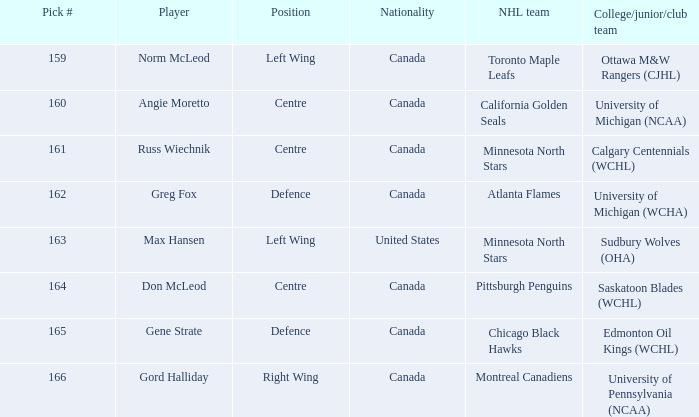How many players have the pick number 166? 1.0. 